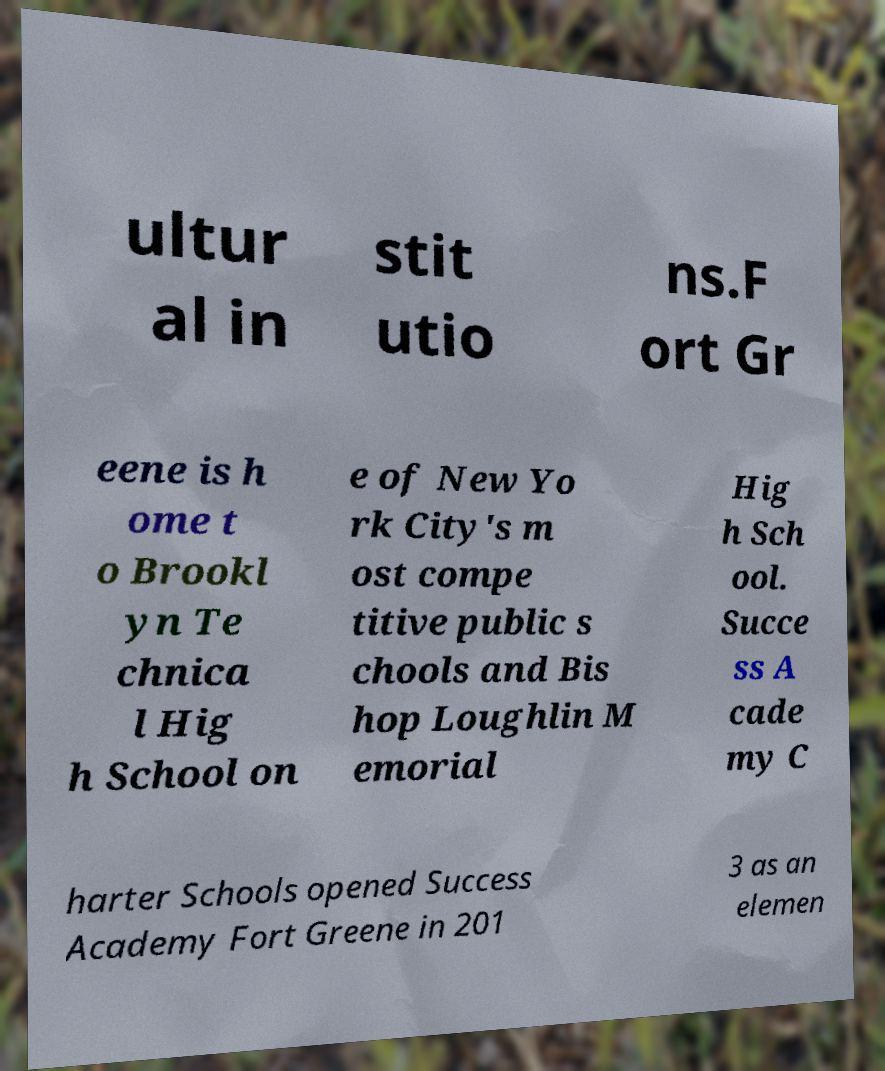Please identify and transcribe the text found in this image. ultur al in stit utio ns.F ort Gr eene is h ome t o Brookl yn Te chnica l Hig h School on e of New Yo rk City's m ost compe titive public s chools and Bis hop Loughlin M emorial Hig h Sch ool. Succe ss A cade my C harter Schools opened Success Academy Fort Greene in 201 3 as an elemen 